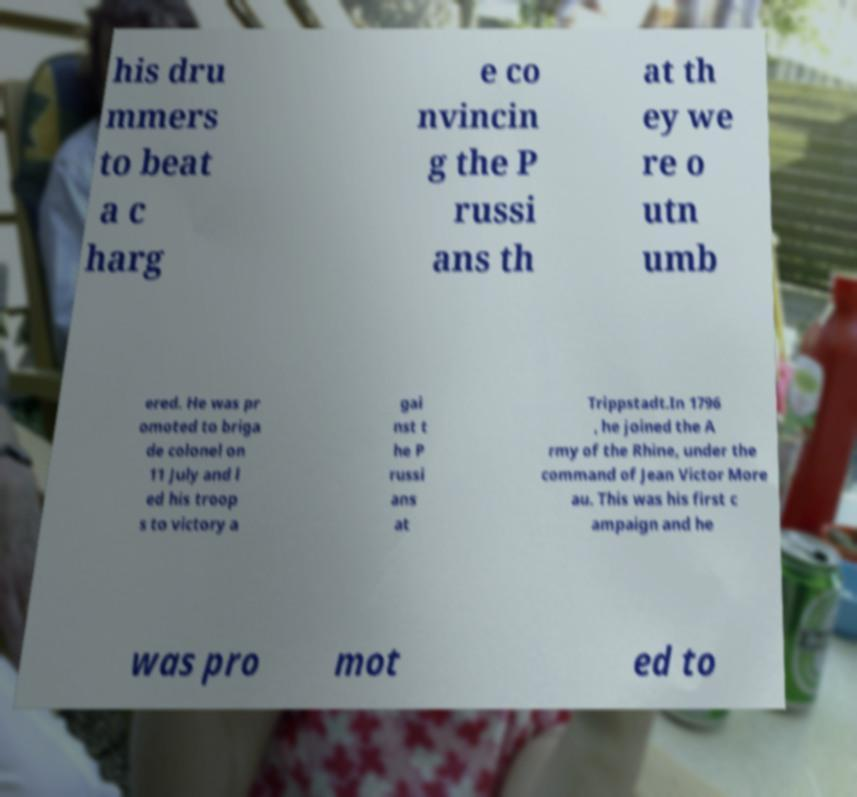Could you extract and type out the text from this image? his dru mmers to beat a c harg e co nvincin g the P russi ans th at th ey we re o utn umb ered. He was pr omoted to briga de colonel on 11 July and l ed his troop s to victory a gai nst t he P russi ans at Trippstadt.In 1796 , he joined the A rmy of the Rhine, under the command of Jean Victor More au. This was his first c ampaign and he was pro mot ed to 